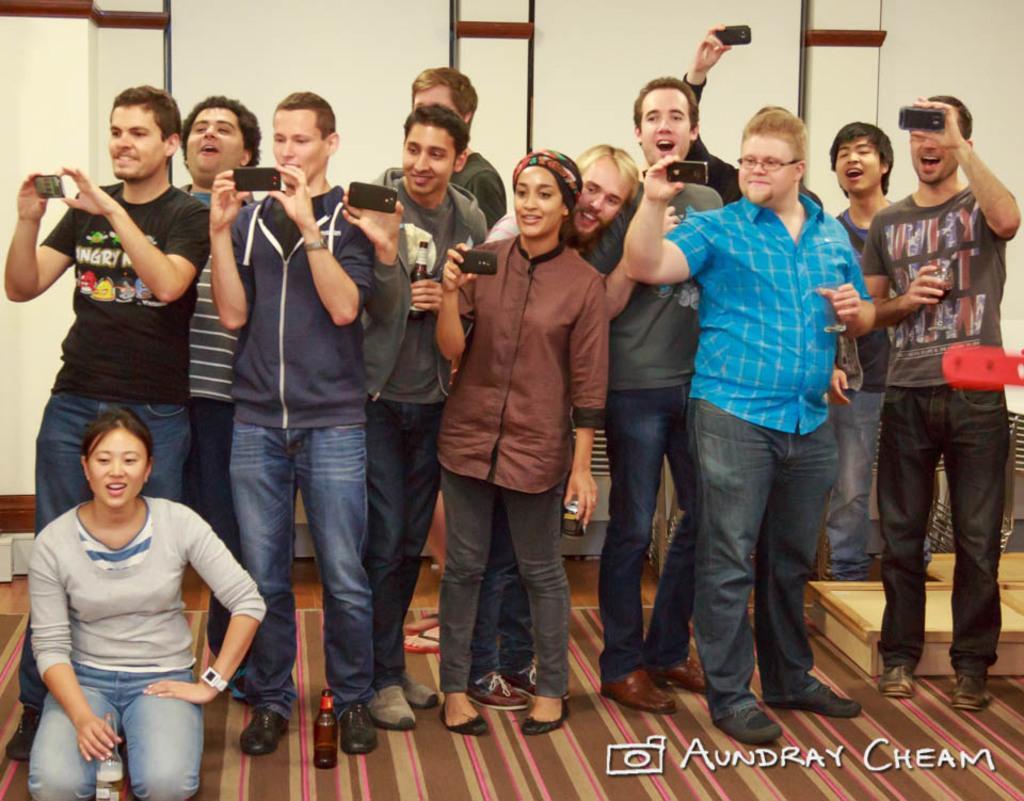Describe this image in one or two sentences. In this image there are a few people standing with a smile on their face and they are holding mobile phones in their hands, one of them is sitting on her knees and holding a bottle in her hand, beside her there is another bottle. In the background there is a wall and at the bottom of the image there is some text. 